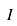<formula> <loc_0><loc_0><loc_500><loc_500>I</formula> 